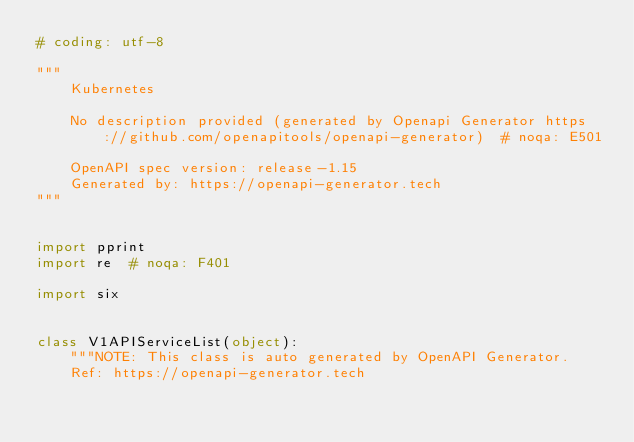<code> <loc_0><loc_0><loc_500><loc_500><_Python_># coding: utf-8

"""
    Kubernetes

    No description provided (generated by Openapi Generator https://github.com/openapitools/openapi-generator)  # noqa: E501

    OpenAPI spec version: release-1.15
    Generated by: https://openapi-generator.tech
"""


import pprint
import re  # noqa: F401

import six


class V1APIServiceList(object):
    """NOTE: This class is auto generated by OpenAPI Generator.
    Ref: https://openapi-generator.tech
</code> 